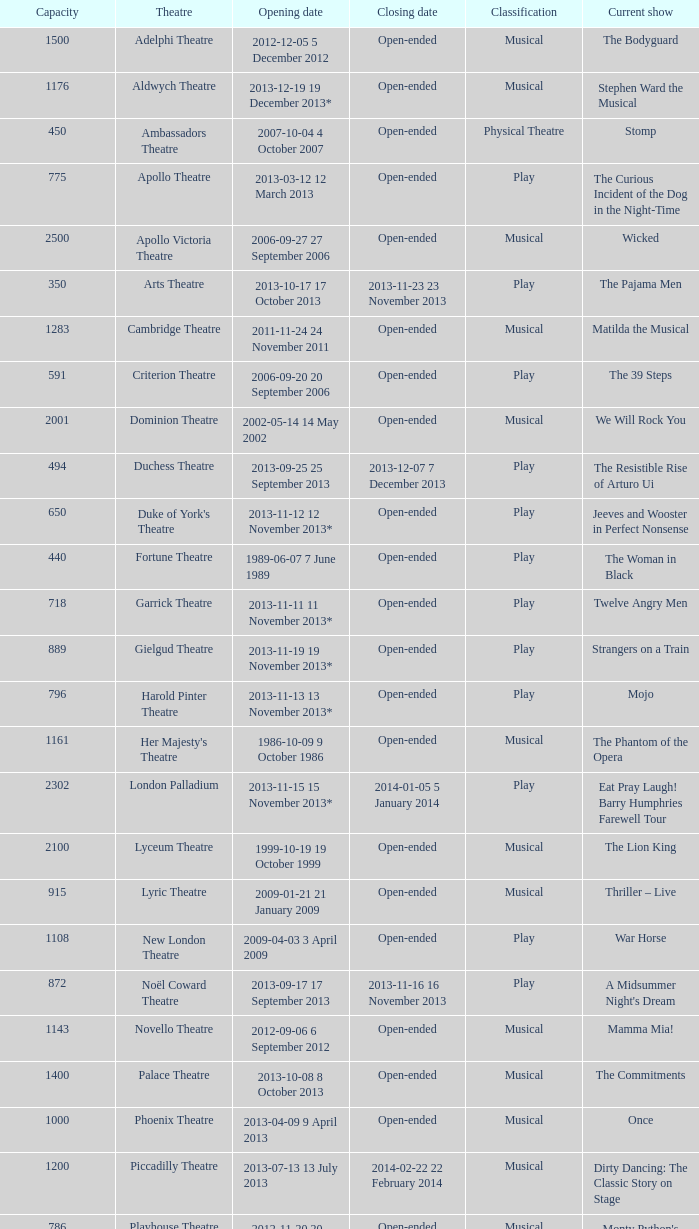What is the opening date of the musical at the adelphi theatre? 2012-12-05 5 December 2012. 